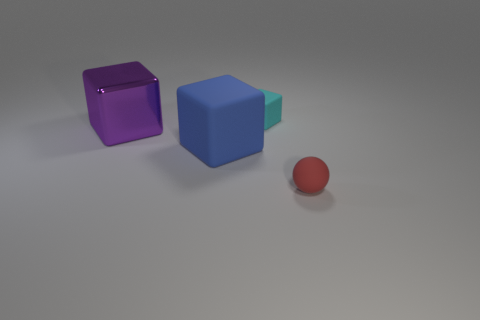What number of objects are either red balls or blocks left of the big blue cube?
Offer a very short reply. 2. There is a block left of the blue matte object; is it the same size as the small cyan matte object?
Offer a terse response. No. There is a rubber thing to the right of the tiny object that is behind the sphere; what number of tiny cyan matte things are in front of it?
Provide a succinct answer. 0. What number of purple things are large objects or metal blocks?
Make the answer very short. 1. What is the color of the tiny ball that is the same material as the large blue thing?
Give a very brief answer. Red. Is there anything else that is the same size as the purple cube?
Keep it short and to the point. Yes. How many tiny objects are either purple shiny blocks or purple metal cylinders?
Your answer should be very brief. 0. Are there fewer big brown balls than large blue rubber cubes?
Your response must be concise. Yes. The tiny rubber thing that is the same shape as the large shiny thing is what color?
Your answer should be compact. Cyan. Are there any other things that are the same shape as the large purple shiny object?
Offer a very short reply. Yes. 